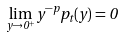Convert formula to latex. <formula><loc_0><loc_0><loc_500><loc_500>\lim _ { y \rightarrow 0 ^ { + } } y ^ { - p } p _ { t } ( y ) = 0</formula> 